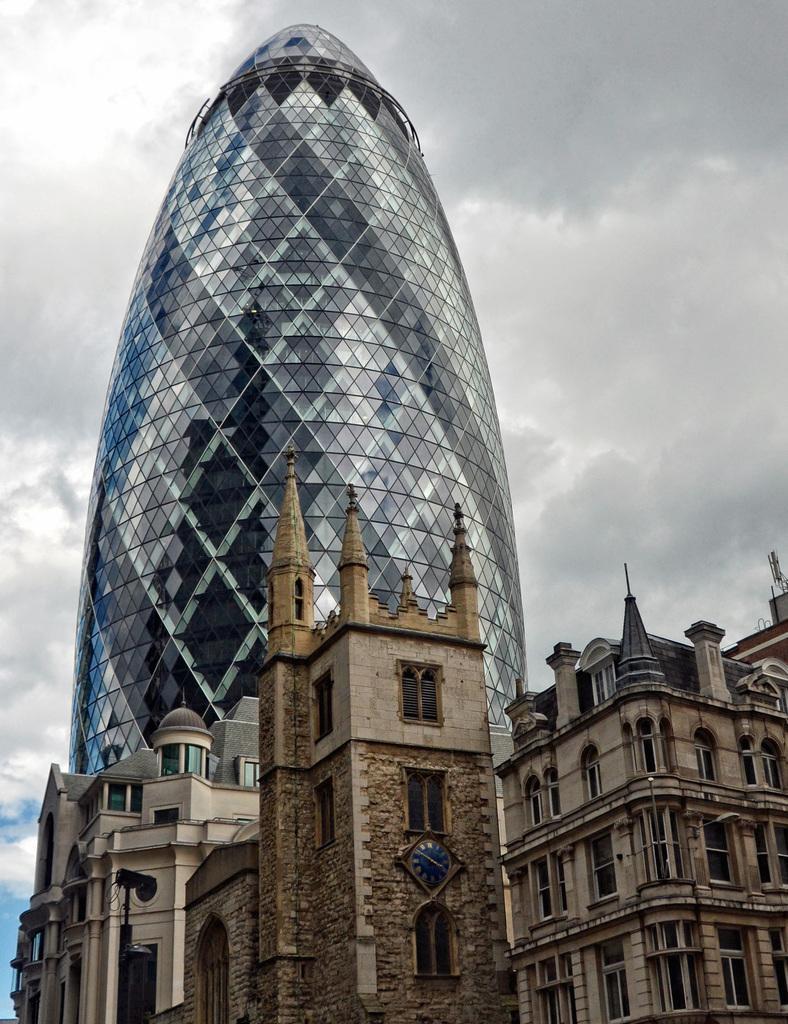Describe this image in one or two sentences. In this image I can see building and windows. In front I can see a clock. The sky is cloudy. We can see a black color pole. 